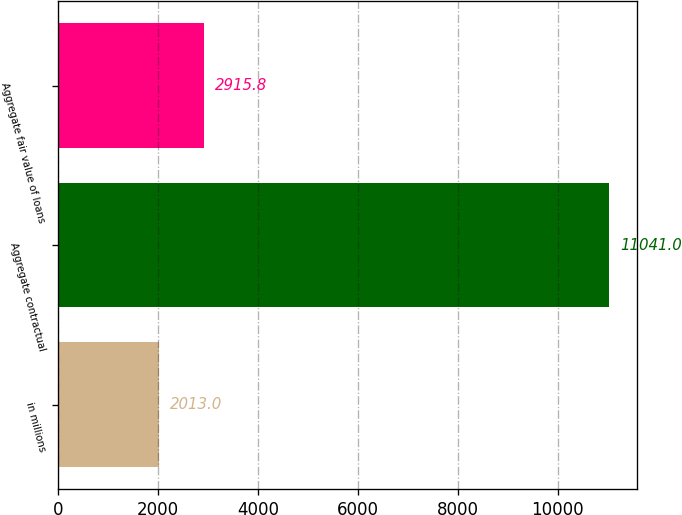Convert chart. <chart><loc_0><loc_0><loc_500><loc_500><bar_chart><fcel>in millions<fcel>Aggregate contractual<fcel>Aggregate fair value of loans<nl><fcel>2013<fcel>11041<fcel>2915.8<nl></chart> 